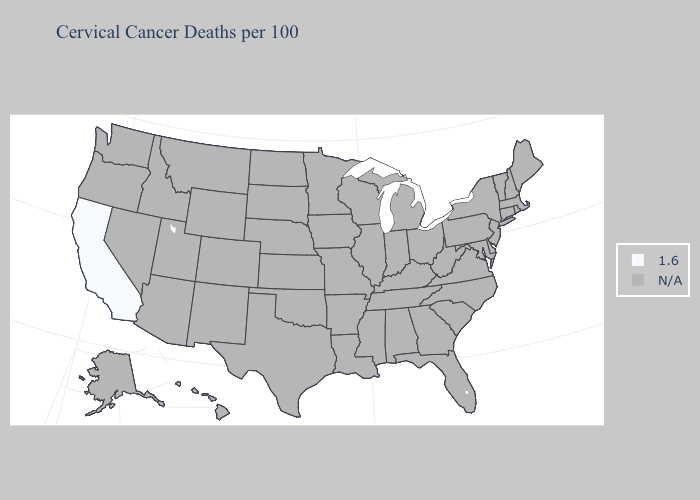What is the value of New Mexico?
Quick response, please. N/A. Name the states that have a value in the range N/A?
Be succinct. Alabama, Alaska, Arizona, Arkansas, Colorado, Connecticut, Delaware, Florida, Georgia, Hawaii, Idaho, Illinois, Indiana, Iowa, Kansas, Kentucky, Louisiana, Maine, Maryland, Massachusetts, Michigan, Minnesota, Mississippi, Missouri, Montana, Nebraska, Nevada, New Hampshire, New Jersey, New Mexico, New York, North Carolina, North Dakota, Ohio, Oklahoma, Oregon, Pennsylvania, Rhode Island, South Carolina, South Dakota, Tennessee, Texas, Utah, Vermont, Virginia, Washington, West Virginia, Wisconsin, Wyoming. Which states have the lowest value in the USA?
Short answer required. California. What is the highest value in the USA?
Answer briefly. 1.6. Name the states that have a value in the range 1.6?
Short answer required. California. What is the value of Oregon?
Concise answer only. N/A. Does the map have missing data?
Be succinct. Yes. Name the states that have a value in the range 1.6?
Concise answer only. California. What is the value of Illinois?
Answer briefly. N/A. 